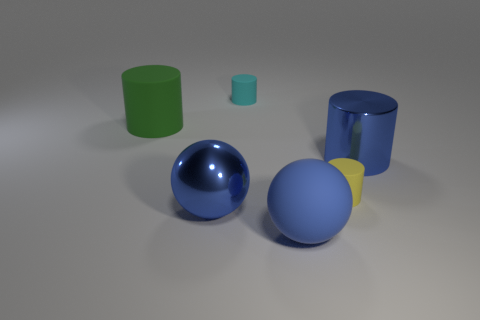Do the metallic cylinder and the cyan rubber object have the same size?
Your answer should be very brief. No. Do the big cylinder that is right of the green rubber object and the large green cylinder have the same material?
Keep it short and to the point. No. There is a large blue thing on the right side of the large rubber thing that is on the right side of the rubber cylinder that is behind the green matte cylinder; what is its material?
Offer a terse response. Metal. What number of other objects are the same shape as the tiny yellow rubber thing?
Offer a very short reply. 3. The large cylinder that is to the left of the large blue shiny cylinder is what color?
Provide a succinct answer. Green. There is a small rubber thing in front of the blue metallic cylinder that is in front of the small cyan rubber cylinder; what number of small rubber objects are to the left of it?
Provide a short and direct response. 1. There is a big cylinder that is in front of the big rubber cylinder; how many things are left of it?
Offer a terse response. 5. There is a large green cylinder; how many large blue rubber balls are left of it?
Your response must be concise. 0. How many other things are the same size as the cyan cylinder?
Ensure brevity in your answer.  1. There is a blue thing that is the same shape as the green object; what size is it?
Offer a very short reply. Large. 